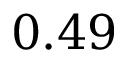<formula> <loc_0><loc_0><loc_500><loc_500>0 . 4 9</formula> 